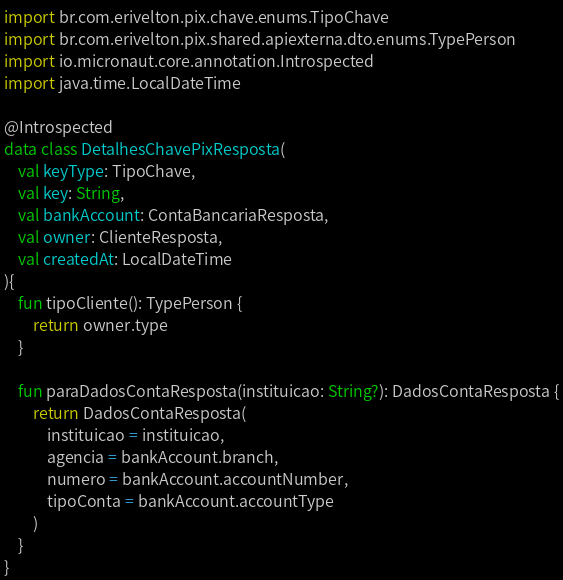<code> <loc_0><loc_0><loc_500><loc_500><_Kotlin_>import br.com.erivelton.pix.chave.enums.TipoChave
import br.com.erivelton.pix.shared.apiexterna.dto.enums.TypePerson
import io.micronaut.core.annotation.Introspected
import java.time.LocalDateTime

@Introspected
data class DetalhesChavePixResposta(
    val keyType: TipoChave,
    val key: String,
    val bankAccount: ContaBancariaResposta,
    val owner: ClienteResposta,
    val createdAt: LocalDateTime
){
    fun tipoCliente(): TypePerson {
        return owner.type
    }

    fun paraDadosContaResposta(instituicao: String?): DadosContaResposta {
        return DadosContaResposta(
            instituicao = instituicao,
            agencia = bankAccount.branch,
            numero = bankAccount.accountNumber,
            tipoConta = bankAccount.accountType
        )
    }
}</code> 